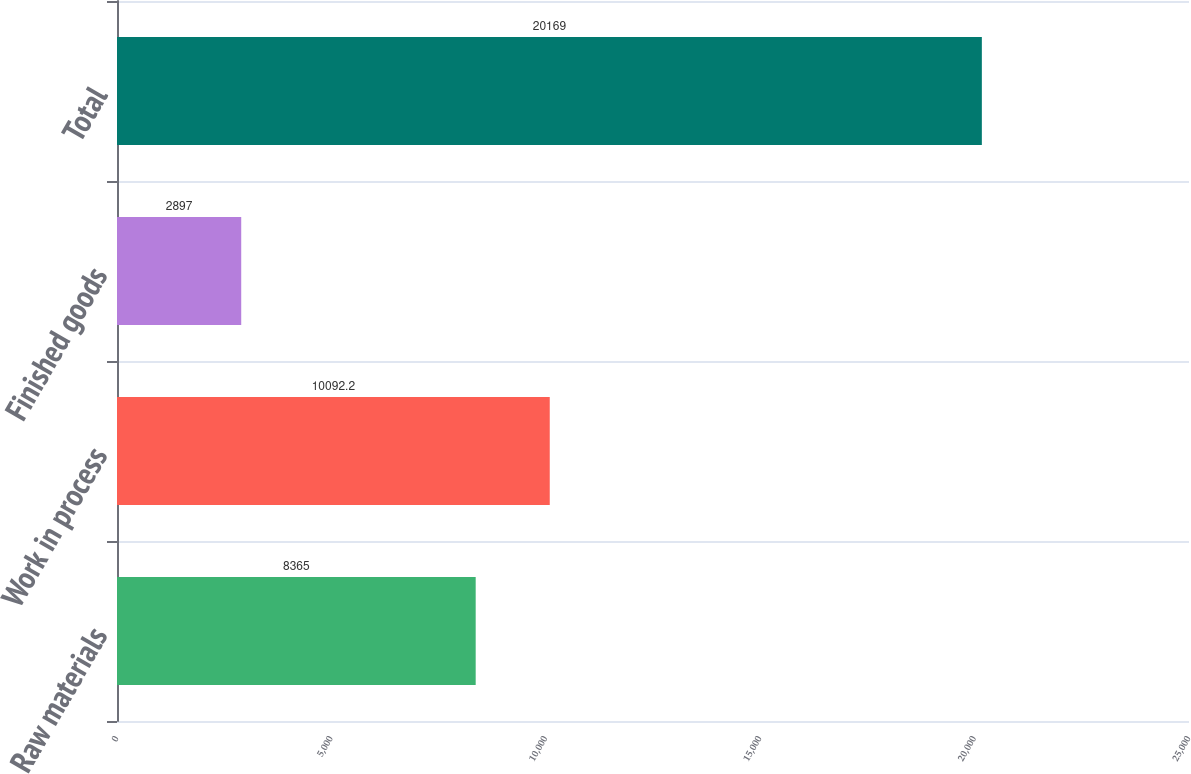Convert chart to OTSL. <chart><loc_0><loc_0><loc_500><loc_500><bar_chart><fcel>Raw materials<fcel>Work in process<fcel>Finished goods<fcel>Total<nl><fcel>8365<fcel>10092.2<fcel>2897<fcel>20169<nl></chart> 